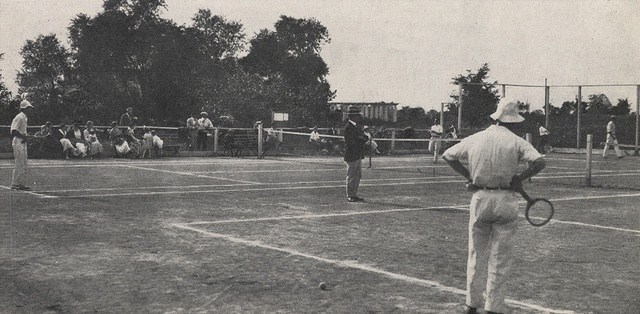Describe the objects in this image and their specific colors. I can see people in lightgray, gray, darkgray, and black tones, people in lightgray, gray, black, and darkgray tones, people in lightgray, black, gray, and darkgray tones, people in lightgray, gray, darkgray, and black tones, and tennis racket in lightgray, gray, black, and darkgray tones in this image. 